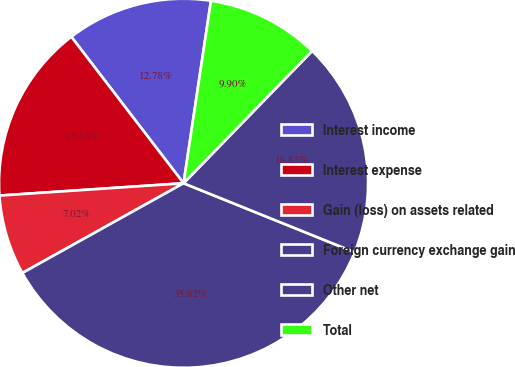<chart> <loc_0><loc_0><loc_500><loc_500><pie_chart><fcel>Interest income<fcel>Interest expense<fcel>Gain (loss) on assets related<fcel>Foreign currency exchange gain<fcel>Other net<fcel>Total<nl><fcel>12.78%<fcel>15.66%<fcel>7.02%<fcel>35.82%<fcel>18.83%<fcel>9.9%<nl></chart> 